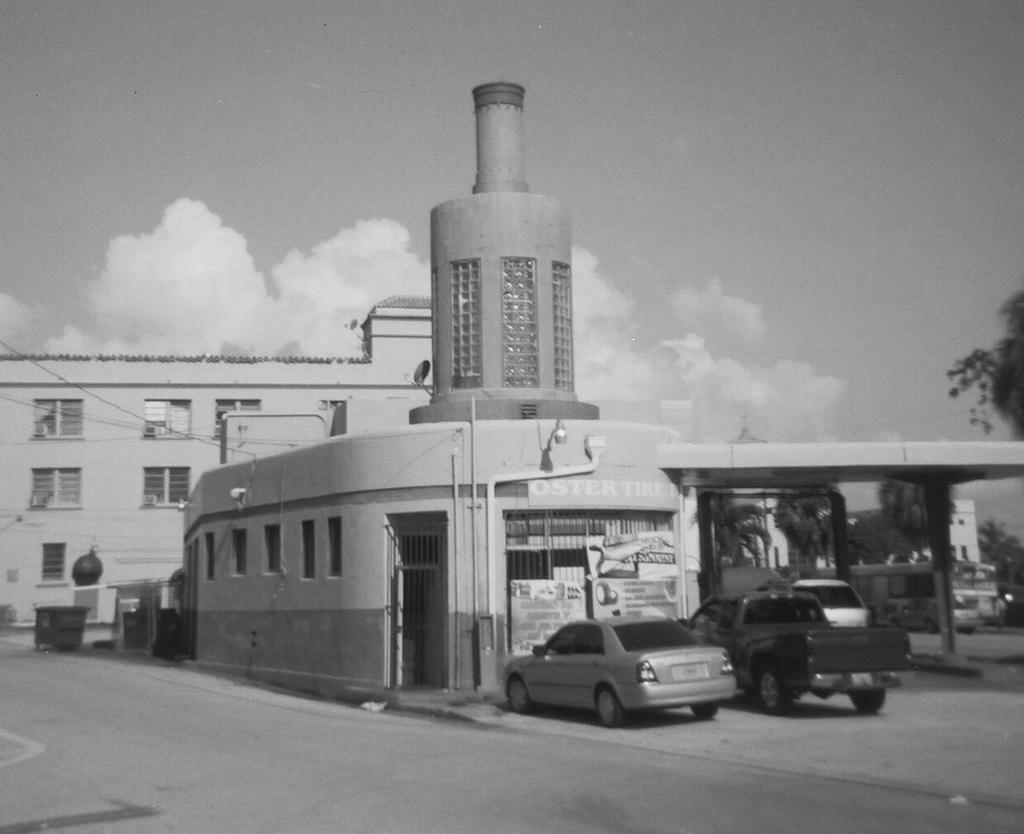In one or two sentences, can you explain what this image depicts? This is the picture of a place where we have some buildings to which there are some windows and around there are some cars, boards to the building and a tree to the side. 